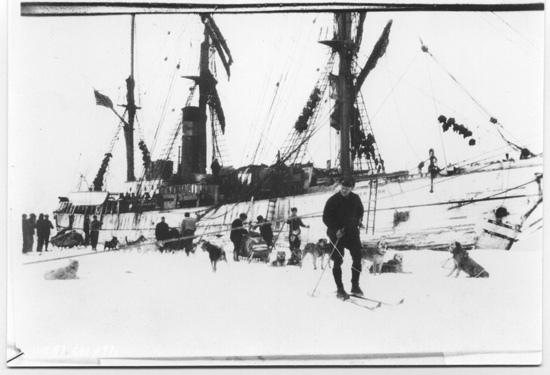What is on the man's feet?
Concise answer only. Skis. Is this a cruise ship?
Give a very brief answer. No. What is covering the ground?
Write a very short answer. Snow. 